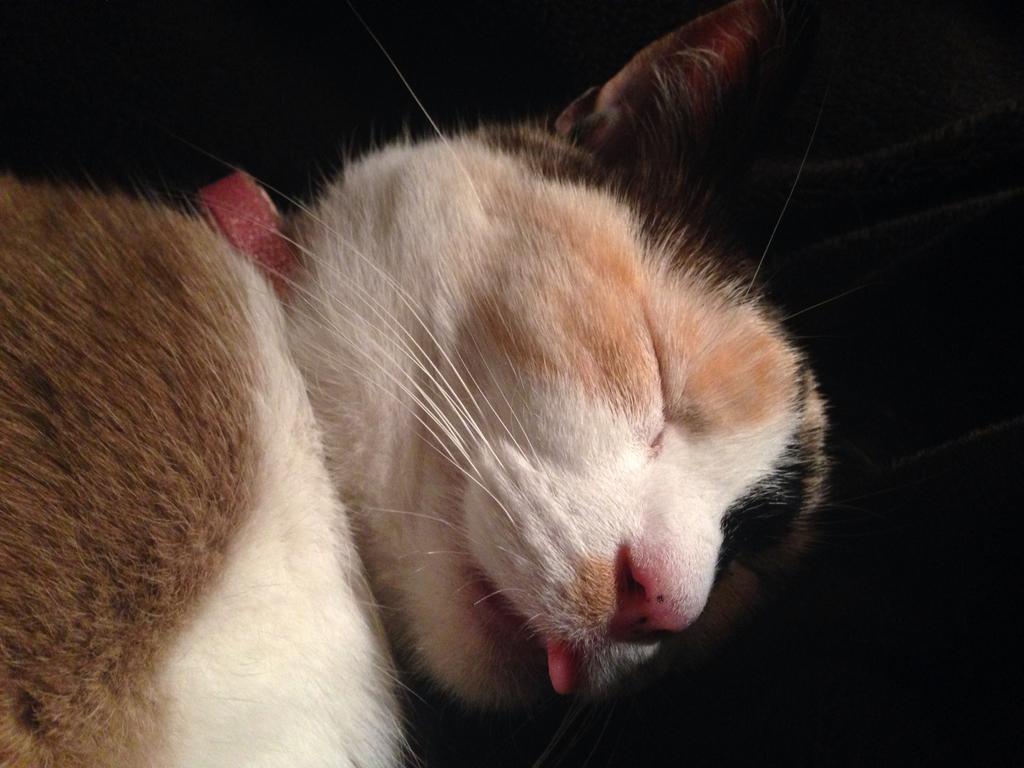In one or two sentences, can you explain what this image depicts? In this image in front there is a cat and it is sleeping. 